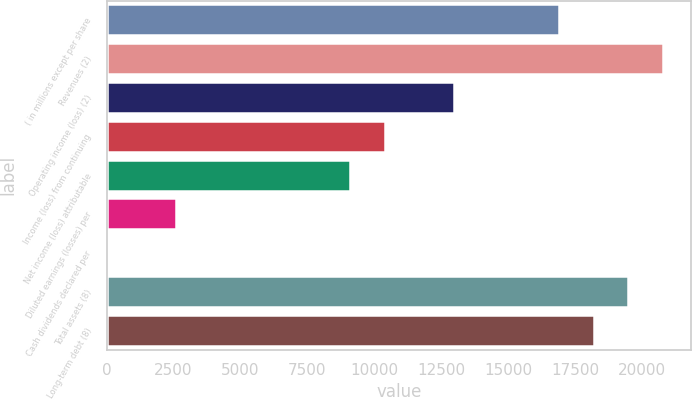Convert chart. <chart><loc_0><loc_0><loc_500><loc_500><bar_chart><fcel>( in millions except per share<fcel>Revenues (2)<fcel>Operating income (loss) (2)<fcel>Income (loss) from continuing<fcel>Net income (loss) attributable<fcel>Diluted earnings (losses) per<fcel>Cash dividends declared per<fcel>Total assets (8)<fcel>Long-term debt (8)<nl><fcel>16886.9<fcel>20783.8<fcel>12990<fcel>10392<fcel>9093.07<fcel>2598.22<fcel>0.28<fcel>19484.8<fcel>18185.9<nl></chart> 